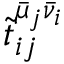<formula> <loc_0><loc_0><loc_500><loc_500>\tilde { t } _ { i j } ^ { \bar { \mu } _ { j } \bar { \nu } _ { i } }</formula> 